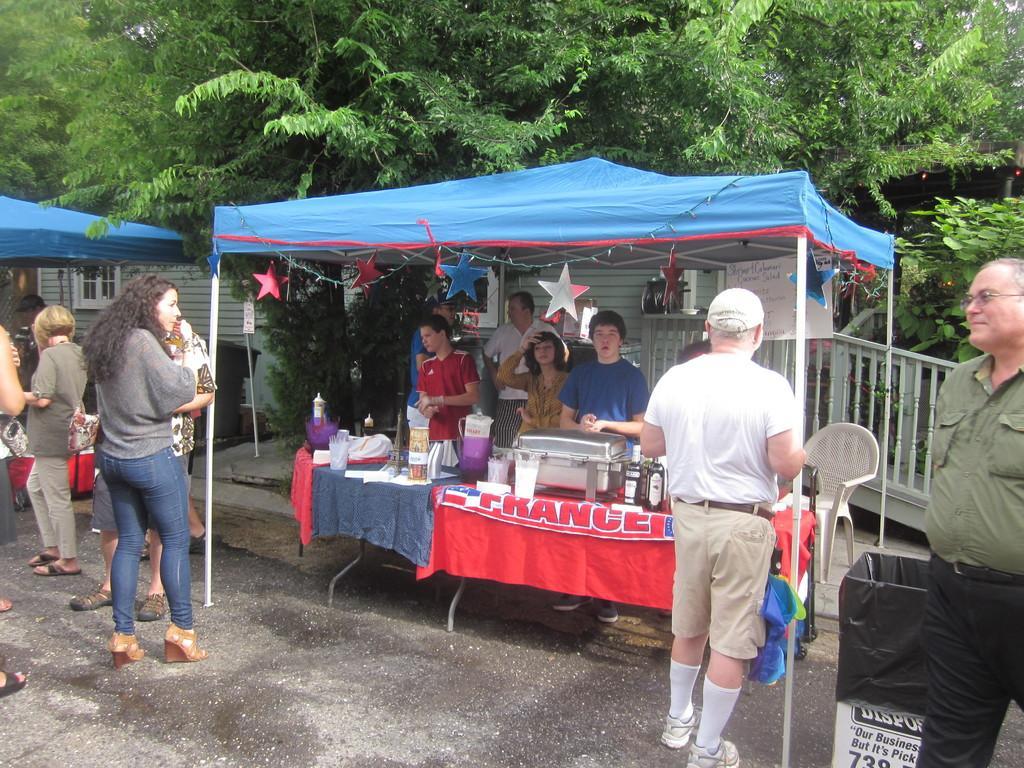In one or two sentences, can you explain what this image depicts? In this picture we can see there are groups of people standing and some people are standing in a stall. In front of the people there is a table and on the table there are some items. Behind the stall there is a house and trees. 